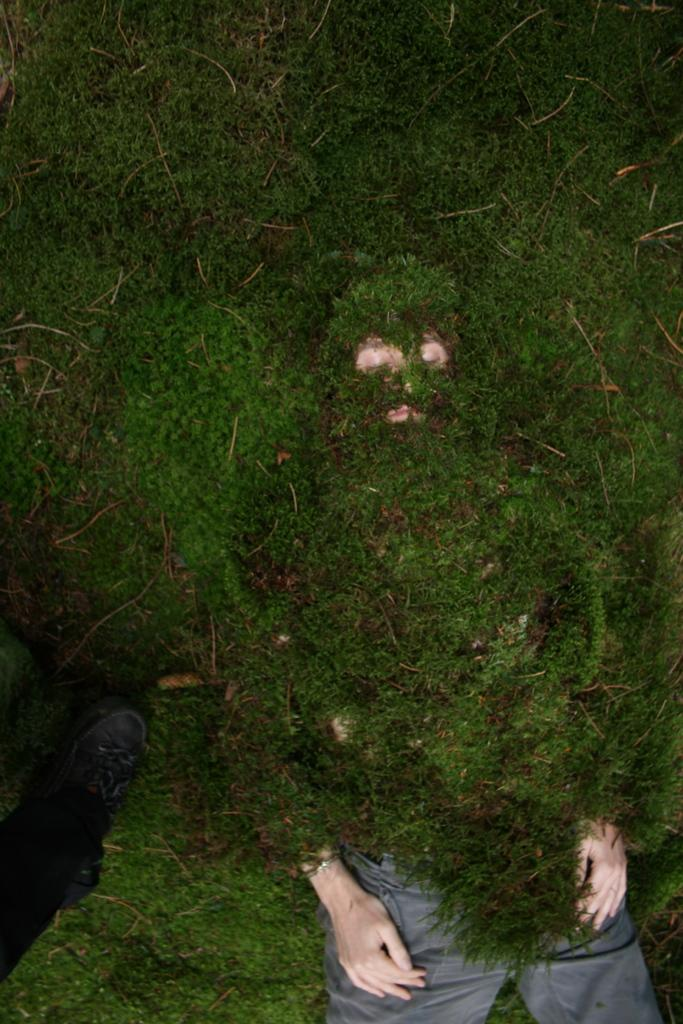Who is present in the image? There is a man in the image. What is the man's position in the image? The man is lying on the ground. What is covering the man in the image? The man is covered with grass. What type of clam can be seen on the man's vest in the image? There is no clam or vest present in the image; the man is covered with grass. 